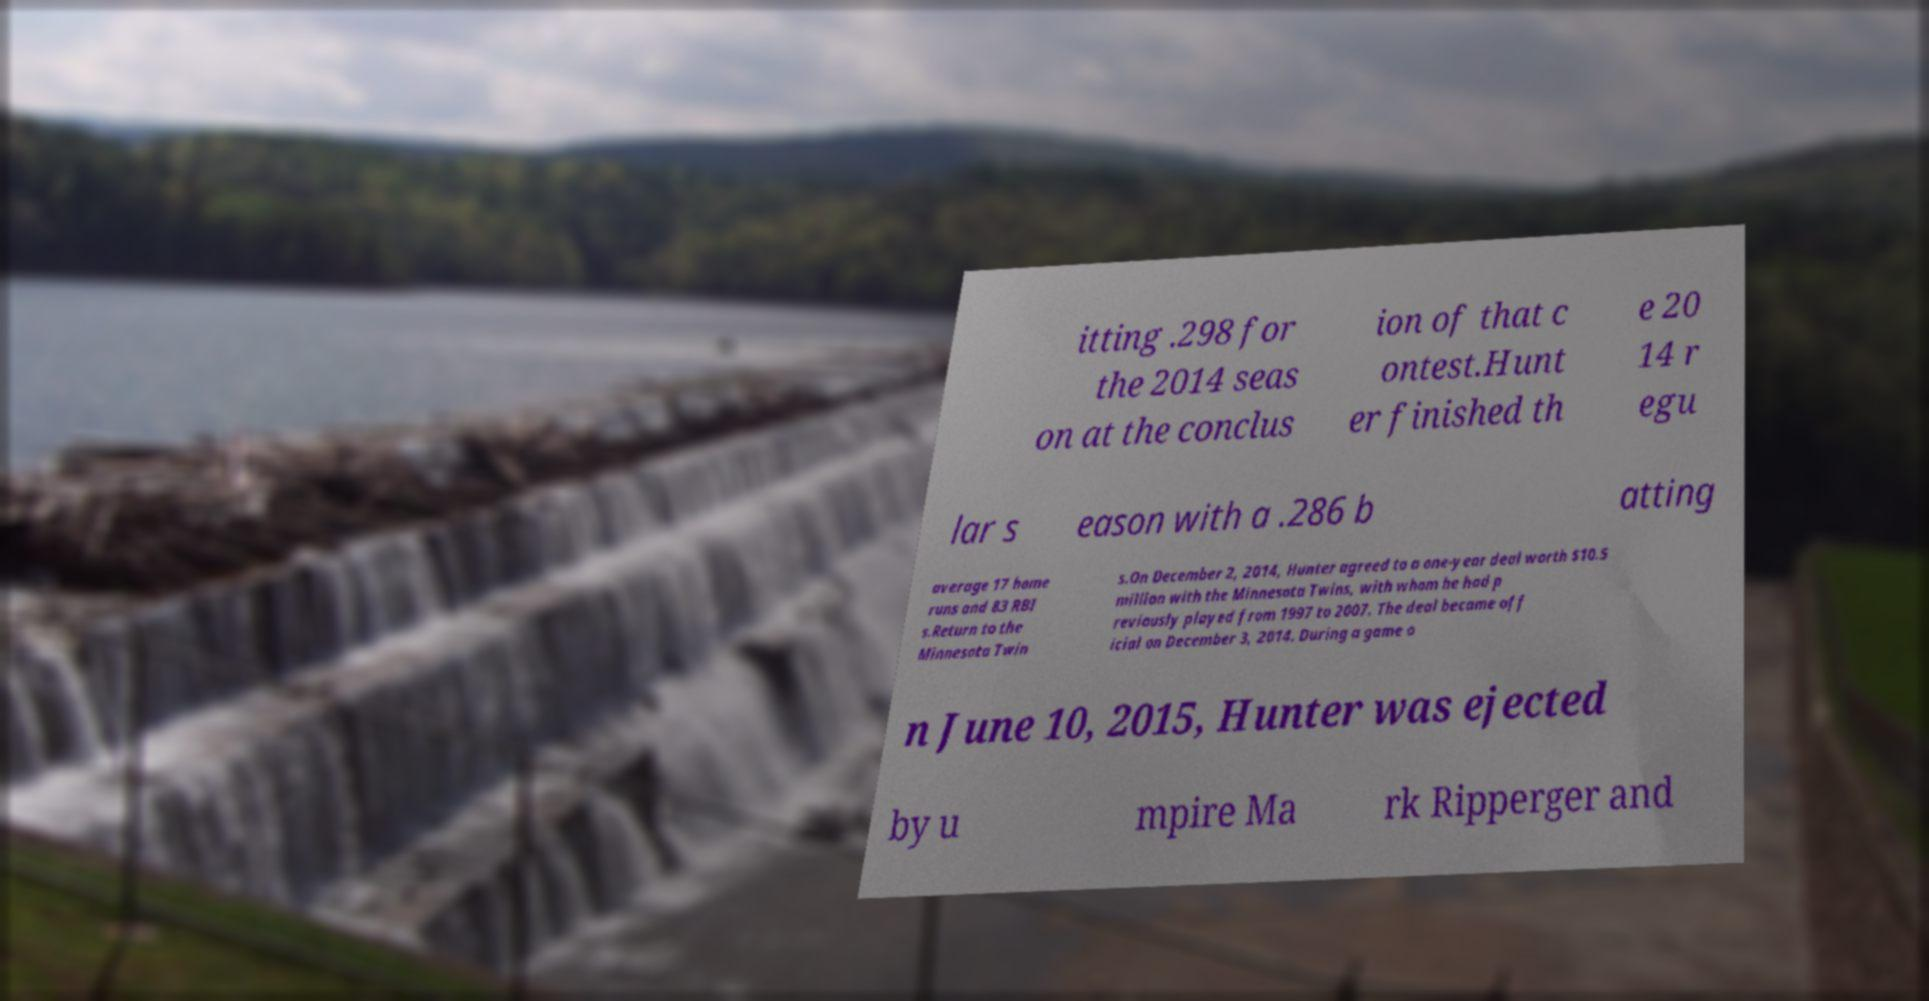Please identify and transcribe the text found in this image. itting .298 for the 2014 seas on at the conclus ion of that c ontest.Hunt er finished th e 20 14 r egu lar s eason with a .286 b atting average 17 home runs and 83 RBI s.Return to the Minnesota Twin s.On December 2, 2014, Hunter agreed to a one-year deal worth $10.5 million with the Minnesota Twins, with whom he had p reviously played from 1997 to 2007. The deal became off icial on December 3, 2014. During a game o n June 10, 2015, Hunter was ejected by u mpire Ma rk Ripperger and 